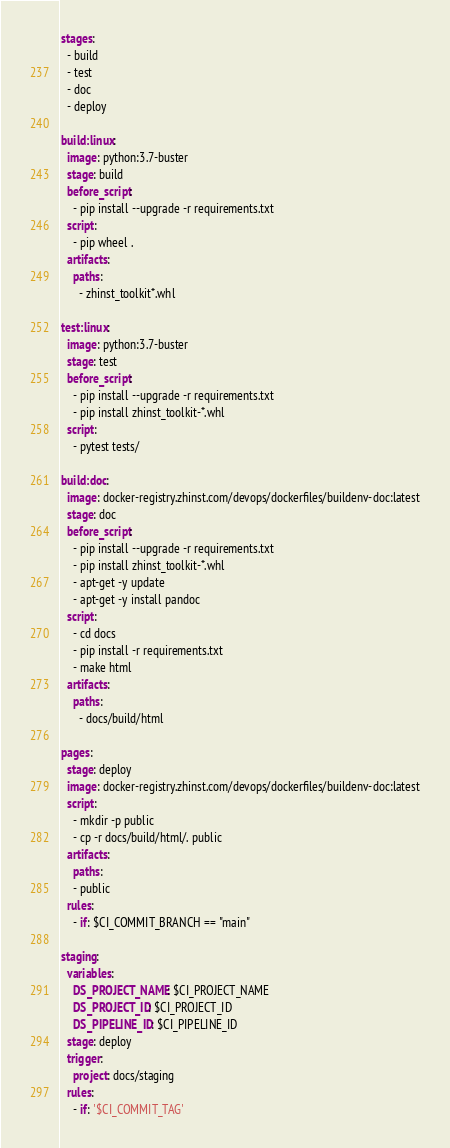Convert code to text. <code><loc_0><loc_0><loc_500><loc_500><_YAML_>stages:
  - build
  - test
  - doc
  - deploy
    
build:linux:
  image: python:3.7-buster
  stage: build
  before_script:
    - pip install --upgrade -r requirements.txt
  script:
    - pip wheel .
  artifacts:
    paths:
      - zhinst_toolkit*.whl  

test:linux:
  image: python:3.7-buster
  stage: test
  before_script:
    - pip install --upgrade -r requirements.txt
    - pip install zhinst_toolkit-*.whl
  script:
    - pytest tests/

build:doc:
  image: docker-registry.zhinst.com/devops/dockerfiles/buildenv-doc:latest
  stage: doc
  before_script:
    - pip install --upgrade -r requirements.txt
    - pip install zhinst_toolkit-*.whl
    - apt-get -y update
    - apt-get -y install pandoc
  script:
    - cd docs
    - pip install -r requirements.txt
    - make html
  artifacts:
    paths:
      - docs/build/html

pages:
  stage: deploy
  image: docker-registry.zhinst.com/devops/dockerfiles/buildenv-doc:latest
  script:
    - mkdir -p public
    - cp -r docs/build/html/. public
  artifacts:
    paths:
    - public
  rules:
    - if: $CI_COMMIT_BRANCH == "main"

staging:
  variables:
    DS_PROJECT_NAME: $CI_PROJECT_NAME
    DS_PROJECT_ID: $CI_PROJECT_ID
    DS_PIPELINE_ID: $CI_PIPELINE_ID
  stage: deploy
  trigger:
    project: docs/staging
  rules:
    - if: '$CI_COMMIT_TAG'
</code> 